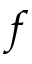Convert formula to latex. <formula><loc_0><loc_0><loc_500><loc_500>f</formula> 